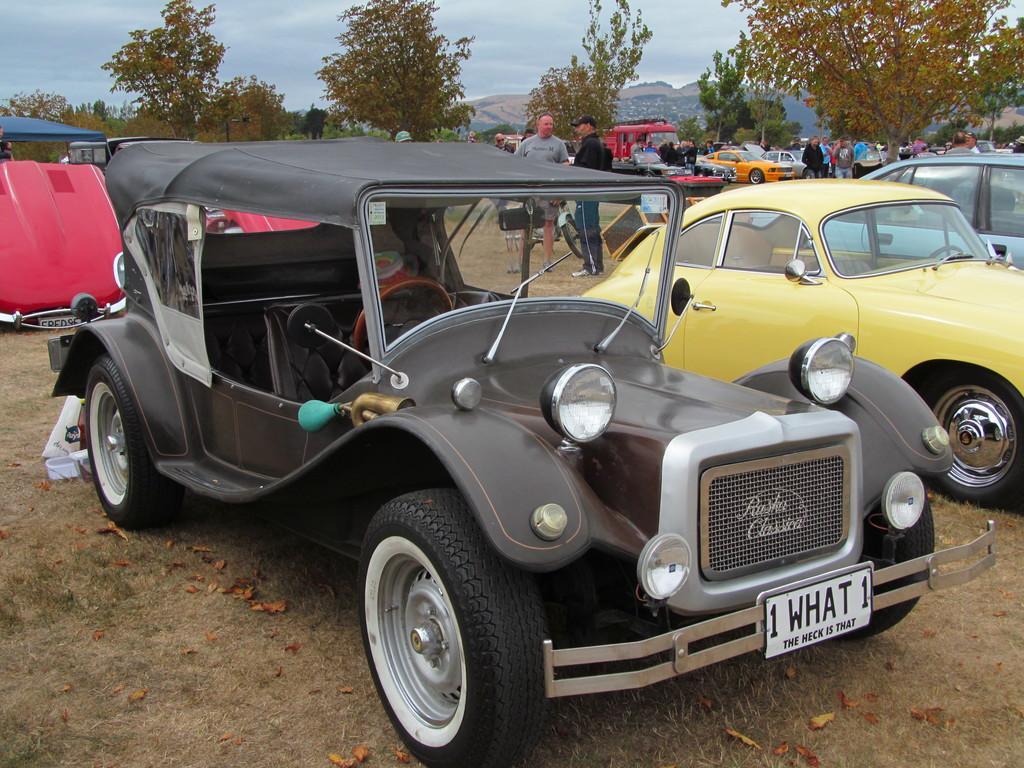Describe this image in one or two sentences. In this picture I can see vehicles, there are group of people standing, there are trees, and in the background there is the sky. 